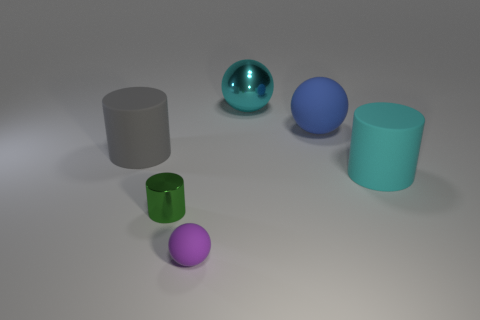There is a cyan ball that is the same size as the gray cylinder; what is it made of?
Offer a very short reply. Metal. How many other objects are the same color as the big metallic thing?
Offer a very short reply. 1. What material is the cyan ball?
Your response must be concise. Metal. How many other things are there of the same material as the small purple sphere?
Ensure brevity in your answer.  3. There is a matte object that is on the right side of the small metal thing and behind the large cyan cylinder; what size is it?
Keep it short and to the point. Large. Do the large metallic ball and the big object right of the large blue ball have the same color?
Give a very brief answer. Yes. There is a object that is both behind the big cyan matte cylinder and on the left side of the metallic ball; what is its color?
Provide a short and direct response. Gray. There is a cyan thing that is behind the cyan cylinder; is its shape the same as the small object that is on the left side of the tiny matte thing?
Make the answer very short. No. How many objects are either tiny green things or yellow balls?
Provide a short and direct response. 1. There is another shiny thing that is the same shape as the blue object; what size is it?
Offer a very short reply. Large. 